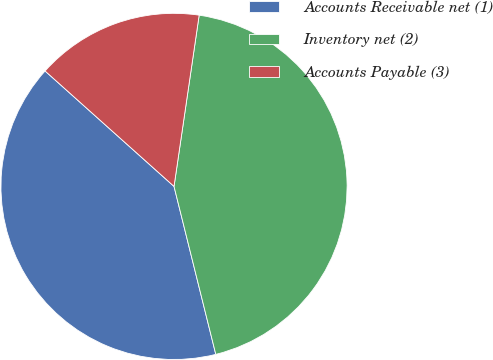Convert chart to OTSL. <chart><loc_0><loc_0><loc_500><loc_500><pie_chart><fcel>Accounts Receivable net (1)<fcel>Inventory net (2)<fcel>Accounts Payable (3)<nl><fcel>40.5%<fcel>43.8%<fcel>15.7%<nl></chart> 